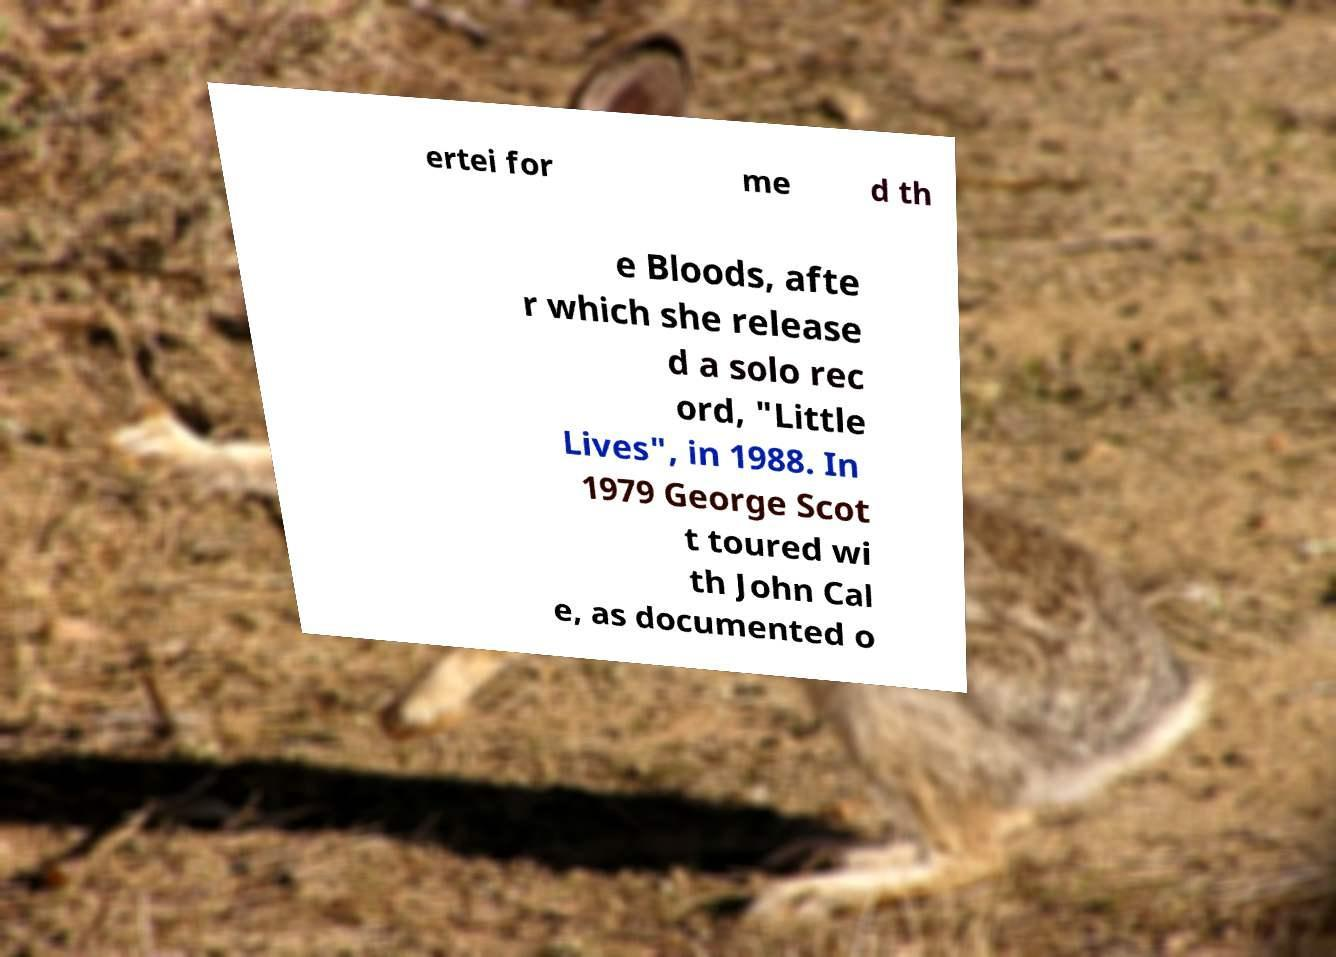Can you accurately transcribe the text from the provided image for me? ertei for me d th e Bloods, afte r which she release d a solo rec ord, "Little Lives", in 1988. In 1979 George Scot t toured wi th John Cal e, as documented o 